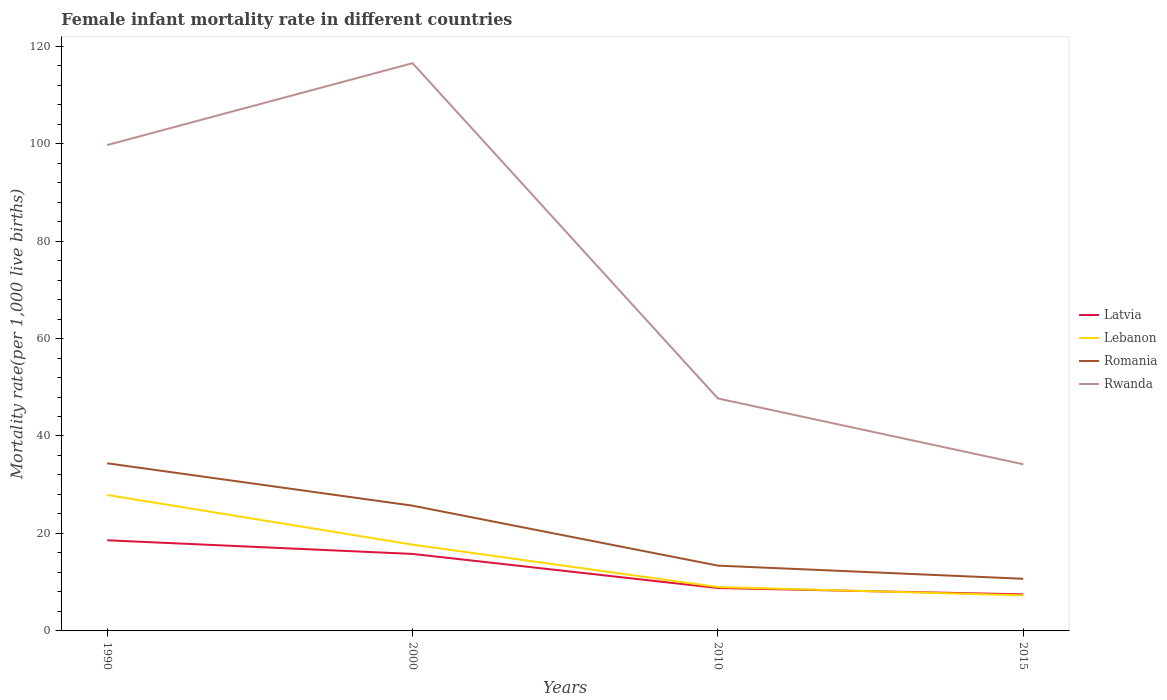Is the number of lines equal to the number of legend labels?
Ensure brevity in your answer.  Yes. In which year was the female infant mortality rate in Latvia maximum?
Keep it short and to the point. 2015. What is the difference between the highest and the second highest female infant mortality rate in Latvia?
Provide a succinct answer. 11.1. What is the difference between the highest and the lowest female infant mortality rate in Lebanon?
Make the answer very short. 2. Is the female infant mortality rate in Lebanon strictly greater than the female infant mortality rate in Latvia over the years?
Your answer should be compact. No. How many years are there in the graph?
Offer a very short reply. 4. What is the difference between two consecutive major ticks on the Y-axis?
Offer a terse response. 20. Are the values on the major ticks of Y-axis written in scientific E-notation?
Provide a succinct answer. No. Does the graph contain grids?
Provide a short and direct response. No. Where does the legend appear in the graph?
Provide a short and direct response. Center right. How are the legend labels stacked?
Offer a very short reply. Vertical. What is the title of the graph?
Provide a short and direct response. Female infant mortality rate in different countries. Does "Ghana" appear as one of the legend labels in the graph?
Provide a short and direct response. No. What is the label or title of the Y-axis?
Make the answer very short. Mortality rate(per 1,0 live births). What is the Mortality rate(per 1,000 live births) of Lebanon in 1990?
Offer a terse response. 27.9. What is the Mortality rate(per 1,000 live births) of Romania in 1990?
Make the answer very short. 34.4. What is the Mortality rate(per 1,000 live births) in Rwanda in 1990?
Give a very brief answer. 99.7. What is the Mortality rate(per 1,000 live births) of Latvia in 2000?
Provide a succinct answer. 15.8. What is the Mortality rate(per 1,000 live births) in Romania in 2000?
Keep it short and to the point. 25.7. What is the Mortality rate(per 1,000 live births) of Rwanda in 2000?
Offer a terse response. 116.5. What is the Mortality rate(per 1,000 live births) of Latvia in 2010?
Ensure brevity in your answer.  8.8. What is the Mortality rate(per 1,000 live births) of Rwanda in 2010?
Make the answer very short. 47.7. What is the Mortality rate(per 1,000 live births) of Romania in 2015?
Ensure brevity in your answer.  10.7. What is the Mortality rate(per 1,000 live births) of Rwanda in 2015?
Your answer should be very brief. 34.2. Across all years, what is the maximum Mortality rate(per 1,000 live births) of Lebanon?
Your response must be concise. 27.9. Across all years, what is the maximum Mortality rate(per 1,000 live births) of Romania?
Give a very brief answer. 34.4. Across all years, what is the maximum Mortality rate(per 1,000 live births) of Rwanda?
Ensure brevity in your answer.  116.5. Across all years, what is the minimum Mortality rate(per 1,000 live births) of Latvia?
Offer a very short reply. 7.5. Across all years, what is the minimum Mortality rate(per 1,000 live births) in Rwanda?
Give a very brief answer. 34.2. What is the total Mortality rate(per 1,000 live births) in Latvia in the graph?
Offer a very short reply. 50.7. What is the total Mortality rate(per 1,000 live births) in Lebanon in the graph?
Keep it short and to the point. 61.9. What is the total Mortality rate(per 1,000 live births) of Romania in the graph?
Your response must be concise. 84.2. What is the total Mortality rate(per 1,000 live births) of Rwanda in the graph?
Offer a terse response. 298.1. What is the difference between the Mortality rate(per 1,000 live births) of Latvia in 1990 and that in 2000?
Your response must be concise. 2.8. What is the difference between the Mortality rate(per 1,000 live births) of Lebanon in 1990 and that in 2000?
Offer a very short reply. 10.2. What is the difference between the Mortality rate(per 1,000 live births) of Rwanda in 1990 and that in 2000?
Give a very brief answer. -16.8. What is the difference between the Mortality rate(per 1,000 live births) of Latvia in 1990 and that in 2010?
Your answer should be very brief. 9.8. What is the difference between the Mortality rate(per 1,000 live births) of Lebanon in 1990 and that in 2010?
Your answer should be compact. 18.9. What is the difference between the Mortality rate(per 1,000 live births) of Romania in 1990 and that in 2010?
Offer a very short reply. 21. What is the difference between the Mortality rate(per 1,000 live births) of Rwanda in 1990 and that in 2010?
Your answer should be compact. 52. What is the difference between the Mortality rate(per 1,000 live births) of Latvia in 1990 and that in 2015?
Keep it short and to the point. 11.1. What is the difference between the Mortality rate(per 1,000 live births) of Lebanon in 1990 and that in 2015?
Offer a terse response. 20.6. What is the difference between the Mortality rate(per 1,000 live births) in Romania in 1990 and that in 2015?
Make the answer very short. 23.7. What is the difference between the Mortality rate(per 1,000 live births) in Rwanda in 1990 and that in 2015?
Provide a short and direct response. 65.5. What is the difference between the Mortality rate(per 1,000 live births) of Lebanon in 2000 and that in 2010?
Give a very brief answer. 8.7. What is the difference between the Mortality rate(per 1,000 live births) in Romania in 2000 and that in 2010?
Provide a succinct answer. 12.3. What is the difference between the Mortality rate(per 1,000 live births) of Rwanda in 2000 and that in 2010?
Ensure brevity in your answer.  68.8. What is the difference between the Mortality rate(per 1,000 live births) of Lebanon in 2000 and that in 2015?
Your answer should be compact. 10.4. What is the difference between the Mortality rate(per 1,000 live births) of Romania in 2000 and that in 2015?
Keep it short and to the point. 15. What is the difference between the Mortality rate(per 1,000 live births) in Rwanda in 2000 and that in 2015?
Your response must be concise. 82.3. What is the difference between the Mortality rate(per 1,000 live births) in Lebanon in 2010 and that in 2015?
Your answer should be compact. 1.7. What is the difference between the Mortality rate(per 1,000 live births) in Romania in 2010 and that in 2015?
Give a very brief answer. 2.7. What is the difference between the Mortality rate(per 1,000 live births) in Rwanda in 2010 and that in 2015?
Your response must be concise. 13.5. What is the difference between the Mortality rate(per 1,000 live births) in Latvia in 1990 and the Mortality rate(per 1,000 live births) in Rwanda in 2000?
Your answer should be compact. -97.9. What is the difference between the Mortality rate(per 1,000 live births) of Lebanon in 1990 and the Mortality rate(per 1,000 live births) of Rwanda in 2000?
Your response must be concise. -88.6. What is the difference between the Mortality rate(per 1,000 live births) of Romania in 1990 and the Mortality rate(per 1,000 live births) of Rwanda in 2000?
Offer a terse response. -82.1. What is the difference between the Mortality rate(per 1,000 live births) in Latvia in 1990 and the Mortality rate(per 1,000 live births) in Lebanon in 2010?
Offer a terse response. 9.6. What is the difference between the Mortality rate(per 1,000 live births) of Latvia in 1990 and the Mortality rate(per 1,000 live births) of Rwanda in 2010?
Offer a very short reply. -29.1. What is the difference between the Mortality rate(per 1,000 live births) of Lebanon in 1990 and the Mortality rate(per 1,000 live births) of Rwanda in 2010?
Make the answer very short. -19.8. What is the difference between the Mortality rate(per 1,000 live births) of Latvia in 1990 and the Mortality rate(per 1,000 live births) of Rwanda in 2015?
Offer a very short reply. -15.6. What is the difference between the Mortality rate(per 1,000 live births) in Lebanon in 1990 and the Mortality rate(per 1,000 live births) in Romania in 2015?
Ensure brevity in your answer.  17.2. What is the difference between the Mortality rate(per 1,000 live births) of Lebanon in 1990 and the Mortality rate(per 1,000 live births) of Rwanda in 2015?
Provide a succinct answer. -6.3. What is the difference between the Mortality rate(per 1,000 live births) in Latvia in 2000 and the Mortality rate(per 1,000 live births) in Rwanda in 2010?
Provide a short and direct response. -31.9. What is the difference between the Mortality rate(per 1,000 live births) in Lebanon in 2000 and the Mortality rate(per 1,000 live births) in Rwanda in 2010?
Provide a short and direct response. -30. What is the difference between the Mortality rate(per 1,000 live births) of Romania in 2000 and the Mortality rate(per 1,000 live births) of Rwanda in 2010?
Keep it short and to the point. -22. What is the difference between the Mortality rate(per 1,000 live births) of Latvia in 2000 and the Mortality rate(per 1,000 live births) of Lebanon in 2015?
Make the answer very short. 8.5. What is the difference between the Mortality rate(per 1,000 live births) of Latvia in 2000 and the Mortality rate(per 1,000 live births) of Romania in 2015?
Provide a succinct answer. 5.1. What is the difference between the Mortality rate(per 1,000 live births) of Latvia in 2000 and the Mortality rate(per 1,000 live births) of Rwanda in 2015?
Make the answer very short. -18.4. What is the difference between the Mortality rate(per 1,000 live births) in Lebanon in 2000 and the Mortality rate(per 1,000 live births) in Rwanda in 2015?
Provide a short and direct response. -16.5. What is the difference between the Mortality rate(per 1,000 live births) of Romania in 2000 and the Mortality rate(per 1,000 live births) of Rwanda in 2015?
Make the answer very short. -8.5. What is the difference between the Mortality rate(per 1,000 live births) of Latvia in 2010 and the Mortality rate(per 1,000 live births) of Lebanon in 2015?
Give a very brief answer. 1.5. What is the difference between the Mortality rate(per 1,000 live births) in Latvia in 2010 and the Mortality rate(per 1,000 live births) in Romania in 2015?
Your response must be concise. -1.9. What is the difference between the Mortality rate(per 1,000 live births) in Latvia in 2010 and the Mortality rate(per 1,000 live births) in Rwanda in 2015?
Give a very brief answer. -25.4. What is the difference between the Mortality rate(per 1,000 live births) of Lebanon in 2010 and the Mortality rate(per 1,000 live births) of Romania in 2015?
Provide a short and direct response. -1.7. What is the difference between the Mortality rate(per 1,000 live births) of Lebanon in 2010 and the Mortality rate(per 1,000 live births) of Rwanda in 2015?
Ensure brevity in your answer.  -25.2. What is the difference between the Mortality rate(per 1,000 live births) of Romania in 2010 and the Mortality rate(per 1,000 live births) of Rwanda in 2015?
Your response must be concise. -20.8. What is the average Mortality rate(per 1,000 live births) in Latvia per year?
Ensure brevity in your answer.  12.68. What is the average Mortality rate(per 1,000 live births) of Lebanon per year?
Provide a succinct answer. 15.47. What is the average Mortality rate(per 1,000 live births) in Romania per year?
Your response must be concise. 21.05. What is the average Mortality rate(per 1,000 live births) in Rwanda per year?
Your answer should be very brief. 74.53. In the year 1990, what is the difference between the Mortality rate(per 1,000 live births) of Latvia and Mortality rate(per 1,000 live births) of Romania?
Your answer should be compact. -15.8. In the year 1990, what is the difference between the Mortality rate(per 1,000 live births) in Latvia and Mortality rate(per 1,000 live births) in Rwanda?
Your response must be concise. -81.1. In the year 1990, what is the difference between the Mortality rate(per 1,000 live births) in Lebanon and Mortality rate(per 1,000 live births) in Rwanda?
Offer a terse response. -71.8. In the year 1990, what is the difference between the Mortality rate(per 1,000 live births) of Romania and Mortality rate(per 1,000 live births) of Rwanda?
Give a very brief answer. -65.3. In the year 2000, what is the difference between the Mortality rate(per 1,000 live births) of Latvia and Mortality rate(per 1,000 live births) of Romania?
Your answer should be compact. -9.9. In the year 2000, what is the difference between the Mortality rate(per 1,000 live births) of Latvia and Mortality rate(per 1,000 live births) of Rwanda?
Give a very brief answer. -100.7. In the year 2000, what is the difference between the Mortality rate(per 1,000 live births) of Lebanon and Mortality rate(per 1,000 live births) of Rwanda?
Make the answer very short. -98.8. In the year 2000, what is the difference between the Mortality rate(per 1,000 live births) of Romania and Mortality rate(per 1,000 live births) of Rwanda?
Your answer should be very brief. -90.8. In the year 2010, what is the difference between the Mortality rate(per 1,000 live births) of Latvia and Mortality rate(per 1,000 live births) of Rwanda?
Make the answer very short. -38.9. In the year 2010, what is the difference between the Mortality rate(per 1,000 live births) of Lebanon and Mortality rate(per 1,000 live births) of Romania?
Ensure brevity in your answer.  -4.4. In the year 2010, what is the difference between the Mortality rate(per 1,000 live births) of Lebanon and Mortality rate(per 1,000 live births) of Rwanda?
Your response must be concise. -38.7. In the year 2010, what is the difference between the Mortality rate(per 1,000 live births) of Romania and Mortality rate(per 1,000 live births) of Rwanda?
Provide a succinct answer. -34.3. In the year 2015, what is the difference between the Mortality rate(per 1,000 live births) in Latvia and Mortality rate(per 1,000 live births) in Lebanon?
Provide a succinct answer. 0.2. In the year 2015, what is the difference between the Mortality rate(per 1,000 live births) of Latvia and Mortality rate(per 1,000 live births) of Rwanda?
Your answer should be compact. -26.7. In the year 2015, what is the difference between the Mortality rate(per 1,000 live births) in Lebanon and Mortality rate(per 1,000 live births) in Rwanda?
Your answer should be compact. -26.9. In the year 2015, what is the difference between the Mortality rate(per 1,000 live births) of Romania and Mortality rate(per 1,000 live births) of Rwanda?
Offer a very short reply. -23.5. What is the ratio of the Mortality rate(per 1,000 live births) in Latvia in 1990 to that in 2000?
Your answer should be compact. 1.18. What is the ratio of the Mortality rate(per 1,000 live births) of Lebanon in 1990 to that in 2000?
Offer a very short reply. 1.58. What is the ratio of the Mortality rate(per 1,000 live births) in Romania in 1990 to that in 2000?
Your response must be concise. 1.34. What is the ratio of the Mortality rate(per 1,000 live births) of Rwanda in 1990 to that in 2000?
Make the answer very short. 0.86. What is the ratio of the Mortality rate(per 1,000 live births) in Latvia in 1990 to that in 2010?
Provide a short and direct response. 2.11. What is the ratio of the Mortality rate(per 1,000 live births) of Romania in 1990 to that in 2010?
Your answer should be very brief. 2.57. What is the ratio of the Mortality rate(per 1,000 live births) in Rwanda in 1990 to that in 2010?
Offer a very short reply. 2.09. What is the ratio of the Mortality rate(per 1,000 live births) of Latvia in 1990 to that in 2015?
Your answer should be very brief. 2.48. What is the ratio of the Mortality rate(per 1,000 live births) of Lebanon in 1990 to that in 2015?
Your answer should be very brief. 3.82. What is the ratio of the Mortality rate(per 1,000 live births) in Romania in 1990 to that in 2015?
Offer a terse response. 3.21. What is the ratio of the Mortality rate(per 1,000 live births) of Rwanda in 1990 to that in 2015?
Your response must be concise. 2.92. What is the ratio of the Mortality rate(per 1,000 live births) in Latvia in 2000 to that in 2010?
Your answer should be compact. 1.8. What is the ratio of the Mortality rate(per 1,000 live births) in Lebanon in 2000 to that in 2010?
Your answer should be compact. 1.97. What is the ratio of the Mortality rate(per 1,000 live births) in Romania in 2000 to that in 2010?
Give a very brief answer. 1.92. What is the ratio of the Mortality rate(per 1,000 live births) of Rwanda in 2000 to that in 2010?
Offer a very short reply. 2.44. What is the ratio of the Mortality rate(per 1,000 live births) of Latvia in 2000 to that in 2015?
Provide a short and direct response. 2.11. What is the ratio of the Mortality rate(per 1,000 live births) of Lebanon in 2000 to that in 2015?
Offer a very short reply. 2.42. What is the ratio of the Mortality rate(per 1,000 live births) of Romania in 2000 to that in 2015?
Offer a very short reply. 2.4. What is the ratio of the Mortality rate(per 1,000 live births) in Rwanda in 2000 to that in 2015?
Your answer should be compact. 3.41. What is the ratio of the Mortality rate(per 1,000 live births) of Latvia in 2010 to that in 2015?
Make the answer very short. 1.17. What is the ratio of the Mortality rate(per 1,000 live births) in Lebanon in 2010 to that in 2015?
Your answer should be very brief. 1.23. What is the ratio of the Mortality rate(per 1,000 live births) in Romania in 2010 to that in 2015?
Give a very brief answer. 1.25. What is the ratio of the Mortality rate(per 1,000 live births) of Rwanda in 2010 to that in 2015?
Keep it short and to the point. 1.39. What is the difference between the highest and the lowest Mortality rate(per 1,000 live births) of Latvia?
Keep it short and to the point. 11.1. What is the difference between the highest and the lowest Mortality rate(per 1,000 live births) in Lebanon?
Provide a succinct answer. 20.6. What is the difference between the highest and the lowest Mortality rate(per 1,000 live births) in Romania?
Give a very brief answer. 23.7. What is the difference between the highest and the lowest Mortality rate(per 1,000 live births) of Rwanda?
Offer a terse response. 82.3. 